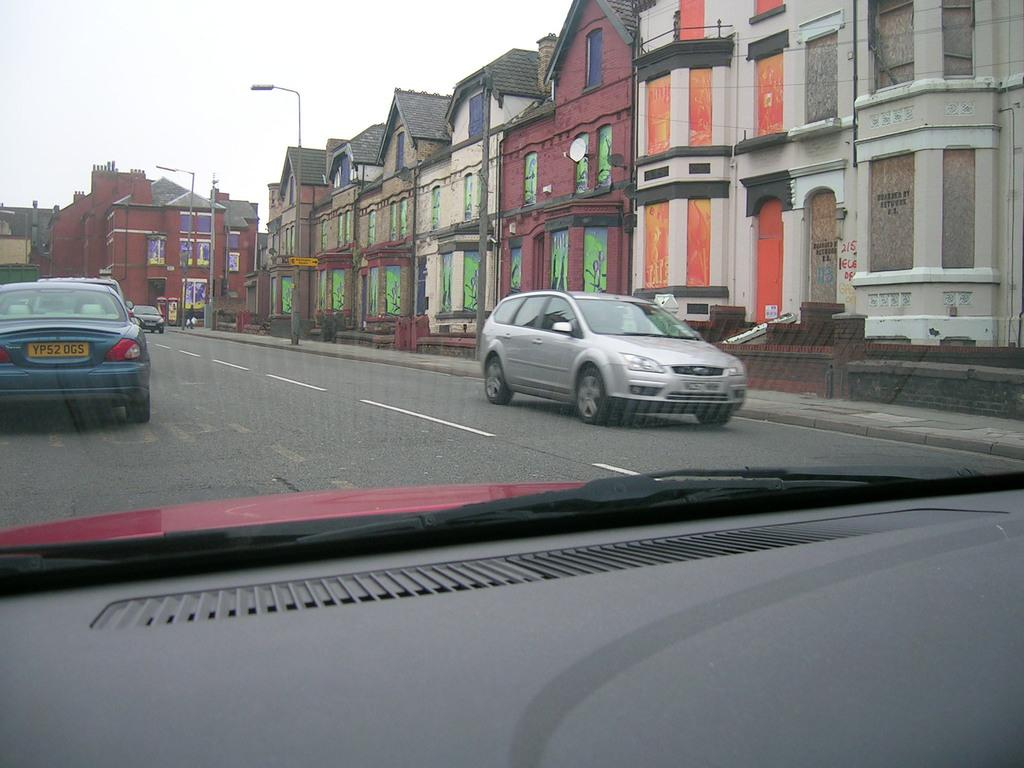What is the setting of the image? The image is from the dashboard of a car. What can be seen on the road in the image? There are vehicles passing on the road. What structures are present beside the road? There are lamp posts beside the road. What else is visible in the background of the image? There are buildings visible in the image. What type of design is featured on the shirt of the person playing the guitar in the image? There is no person playing a guitar in the image; it is a view from the dashboard of a car. 